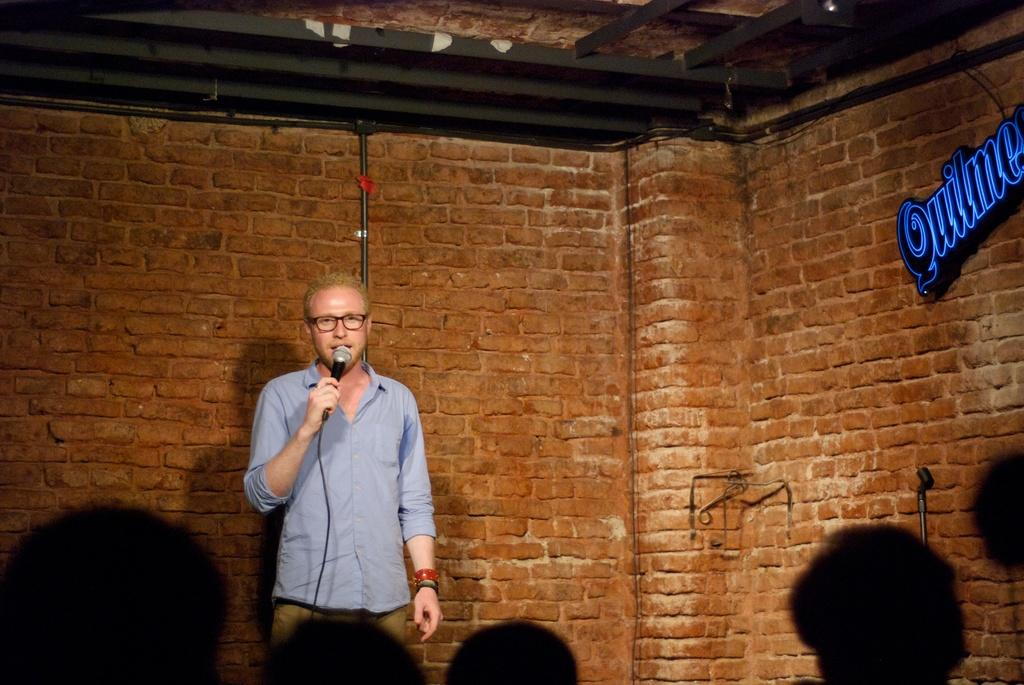What is the person in the image doing? The person is standing in the image and holding a microphone in his hand. What object is the person holding? The person is holding a microphone in his hand. What can be seen in the background of the image? There is a wall made of bricks in the background of the image. What type of toothbrush is the person using in the image? There is no toothbrush present in the image; the person is holding a microphone. Can you tell me how many trucks are visible in the image? There are no trucks visible in the image. 